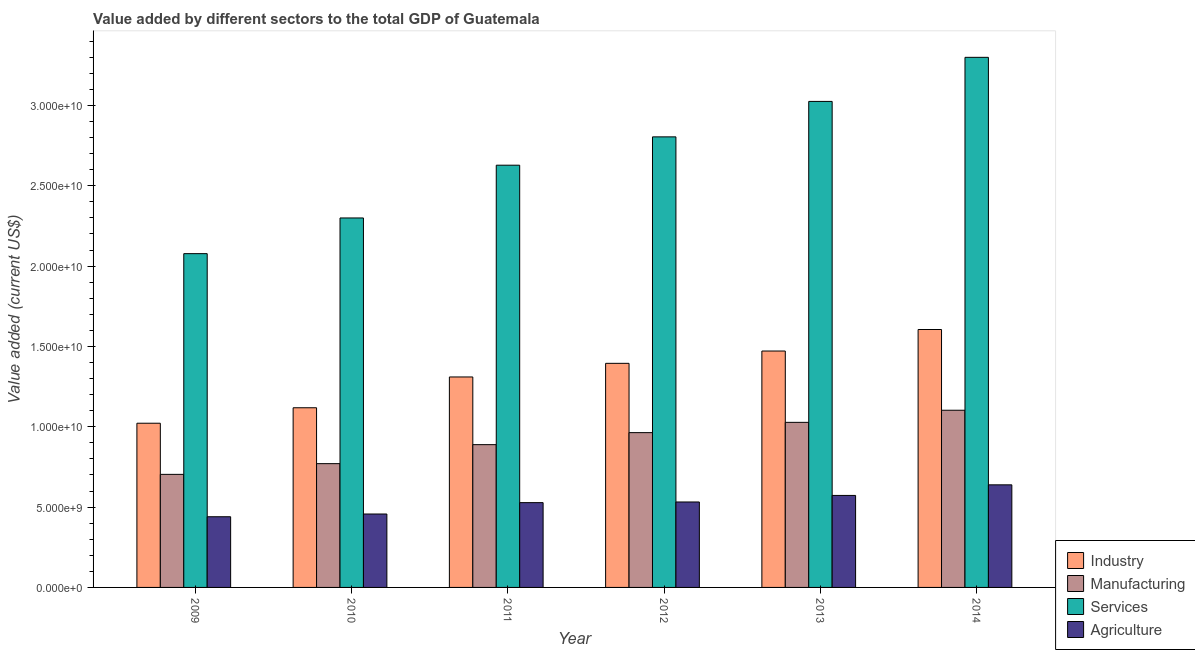Are the number of bars per tick equal to the number of legend labels?
Offer a terse response. Yes. In how many cases, is the number of bars for a given year not equal to the number of legend labels?
Keep it short and to the point. 0. What is the value added by industrial sector in 2011?
Your response must be concise. 1.31e+1. Across all years, what is the maximum value added by industrial sector?
Give a very brief answer. 1.61e+1. Across all years, what is the minimum value added by industrial sector?
Your answer should be compact. 1.02e+1. What is the total value added by industrial sector in the graph?
Offer a terse response. 7.92e+1. What is the difference between the value added by agricultural sector in 2011 and that in 2014?
Offer a terse response. -1.11e+09. What is the difference between the value added by agricultural sector in 2009 and the value added by services sector in 2012?
Provide a succinct answer. -9.19e+08. What is the average value added by industrial sector per year?
Keep it short and to the point. 1.32e+1. What is the ratio of the value added by services sector in 2009 to that in 2013?
Ensure brevity in your answer.  0.69. Is the value added by manufacturing sector in 2009 less than that in 2011?
Make the answer very short. Yes. Is the difference between the value added by services sector in 2011 and 2012 greater than the difference between the value added by industrial sector in 2011 and 2012?
Offer a terse response. No. What is the difference between the highest and the second highest value added by manufacturing sector?
Your response must be concise. 7.54e+08. What is the difference between the highest and the lowest value added by agricultural sector?
Your answer should be very brief. 1.99e+09. In how many years, is the value added by services sector greater than the average value added by services sector taken over all years?
Make the answer very short. 3. What does the 2nd bar from the left in 2010 represents?
Give a very brief answer. Manufacturing. What does the 3rd bar from the right in 2011 represents?
Your answer should be compact. Manufacturing. Does the graph contain grids?
Make the answer very short. No. Where does the legend appear in the graph?
Give a very brief answer. Bottom right. How many legend labels are there?
Give a very brief answer. 4. What is the title of the graph?
Your response must be concise. Value added by different sectors to the total GDP of Guatemala. Does "WHO" appear as one of the legend labels in the graph?
Provide a short and direct response. No. What is the label or title of the Y-axis?
Provide a short and direct response. Value added (current US$). What is the Value added (current US$) in Industry in 2009?
Your answer should be compact. 1.02e+1. What is the Value added (current US$) in Manufacturing in 2009?
Keep it short and to the point. 7.04e+09. What is the Value added (current US$) of Services in 2009?
Provide a short and direct response. 2.08e+1. What is the Value added (current US$) in Agriculture in 2009?
Give a very brief answer. 4.40e+09. What is the Value added (current US$) in Industry in 2010?
Give a very brief answer. 1.12e+1. What is the Value added (current US$) of Manufacturing in 2010?
Your answer should be very brief. 7.70e+09. What is the Value added (current US$) in Services in 2010?
Provide a succinct answer. 2.30e+1. What is the Value added (current US$) of Agriculture in 2010?
Offer a very short reply. 4.57e+09. What is the Value added (current US$) of Industry in 2011?
Your response must be concise. 1.31e+1. What is the Value added (current US$) of Manufacturing in 2011?
Keep it short and to the point. 8.89e+09. What is the Value added (current US$) of Services in 2011?
Keep it short and to the point. 2.63e+1. What is the Value added (current US$) in Agriculture in 2011?
Your answer should be very brief. 5.28e+09. What is the Value added (current US$) in Industry in 2012?
Your response must be concise. 1.39e+1. What is the Value added (current US$) of Manufacturing in 2012?
Offer a terse response. 9.63e+09. What is the Value added (current US$) of Services in 2012?
Your answer should be compact. 2.80e+1. What is the Value added (current US$) in Agriculture in 2012?
Ensure brevity in your answer.  5.32e+09. What is the Value added (current US$) of Industry in 2013?
Keep it short and to the point. 1.47e+1. What is the Value added (current US$) in Manufacturing in 2013?
Your answer should be very brief. 1.03e+1. What is the Value added (current US$) of Services in 2013?
Make the answer very short. 3.02e+1. What is the Value added (current US$) of Agriculture in 2013?
Provide a succinct answer. 5.73e+09. What is the Value added (current US$) in Industry in 2014?
Keep it short and to the point. 1.61e+1. What is the Value added (current US$) in Manufacturing in 2014?
Your answer should be compact. 1.10e+1. What is the Value added (current US$) in Services in 2014?
Offer a terse response. 3.30e+1. What is the Value added (current US$) of Agriculture in 2014?
Offer a terse response. 6.38e+09. Across all years, what is the maximum Value added (current US$) in Industry?
Your answer should be very brief. 1.61e+1. Across all years, what is the maximum Value added (current US$) of Manufacturing?
Your answer should be very brief. 1.10e+1. Across all years, what is the maximum Value added (current US$) in Services?
Keep it short and to the point. 3.30e+1. Across all years, what is the maximum Value added (current US$) in Agriculture?
Provide a short and direct response. 6.38e+09. Across all years, what is the minimum Value added (current US$) in Industry?
Your response must be concise. 1.02e+1. Across all years, what is the minimum Value added (current US$) of Manufacturing?
Ensure brevity in your answer.  7.04e+09. Across all years, what is the minimum Value added (current US$) of Services?
Provide a short and direct response. 2.08e+1. Across all years, what is the minimum Value added (current US$) in Agriculture?
Offer a terse response. 4.40e+09. What is the total Value added (current US$) of Industry in the graph?
Offer a terse response. 7.92e+1. What is the total Value added (current US$) of Manufacturing in the graph?
Offer a very short reply. 5.46e+1. What is the total Value added (current US$) of Services in the graph?
Provide a succinct answer. 1.61e+11. What is the total Value added (current US$) in Agriculture in the graph?
Make the answer very short. 3.17e+1. What is the difference between the Value added (current US$) of Industry in 2009 and that in 2010?
Keep it short and to the point. -9.63e+08. What is the difference between the Value added (current US$) in Manufacturing in 2009 and that in 2010?
Provide a short and direct response. -6.67e+08. What is the difference between the Value added (current US$) of Services in 2009 and that in 2010?
Your answer should be very brief. -2.22e+09. What is the difference between the Value added (current US$) of Agriculture in 2009 and that in 2010?
Keep it short and to the point. -1.71e+08. What is the difference between the Value added (current US$) of Industry in 2009 and that in 2011?
Give a very brief answer. -2.88e+09. What is the difference between the Value added (current US$) of Manufacturing in 2009 and that in 2011?
Keep it short and to the point. -1.85e+09. What is the difference between the Value added (current US$) of Services in 2009 and that in 2011?
Provide a succinct answer. -5.50e+09. What is the difference between the Value added (current US$) in Agriculture in 2009 and that in 2011?
Keep it short and to the point. -8.79e+08. What is the difference between the Value added (current US$) in Industry in 2009 and that in 2012?
Ensure brevity in your answer.  -3.73e+09. What is the difference between the Value added (current US$) in Manufacturing in 2009 and that in 2012?
Your answer should be compact. -2.60e+09. What is the difference between the Value added (current US$) of Services in 2009 and that in 2012?
Ensure brevity in your answer.  -7.27e+09. What is the difference between the Value added (current US$) of Agriculture in 2009 and that in 2012?
Offer a terse response. -9.19e+08. What is the difference between the Value added (current US$) in Industry in 2009 and that in 2013?
Provide a succinct answer. -4.49e+09. What is the difference between the Value added (current US$) of Manufacturing in 2009 and that in 2013?
Give a very brief answer. -3.24e+09. What is the difference between the Value added (current US$) in Services in 2009 and that in 2013?
Your answer should be very brief. -9.47e+09. What is the difference between the Value added (current US$) of Agriculture in 2009 and that in 2013?
Your response must be concise. -1.33e+09. What is the difference between the Value added (current US$) of Industry in 2009 and that in 2014?
Provide a short and direct response. -5.83e+09. What is the difference between the Value added (current US$) of Manufacturing in 2009 and that in 2014?
Keep it short and to the point. -3.99e+09. What is the difference between the Value added (current US$) of Services in 2009 and that in 2014?
Your answer should be compact. -1.22e+1. What is the difference between the Value added (current US$) of Agriculture in 2009 and that in 2014?
Give a very brief answer. -1.99e+09. What is the difference between the Value added (current US$) in Industry in 2010 and that in 2011?
Your answer should be compact. -1.92e+09. What is the difference between the Value added (current US$) of Manufacturing in 2010 and that in 2011?
Keep it short and to the point. -1.18e+09. What is the difference between the Value added (current US$) in Services in 2010 and that in 2011?
Provide a short and direct response. -3.28e+09. What is the difference between the Value added (current US$) in Agriculture in 2010 and that in 2011?
Offer a very short reply. -7.08e+08. What is the difference between the Value added (current US$) in Industry in 2010 and that in 2012?
Provide a short and direct response. -2.76e+09. What is the difference between the Value added (current US$) of Manufacturing in 2010 and that in 2012?
Provide a short and direct response. -1.93e+09. What is the difference between the Value added (current US$) of Services in 2010 and that in 2012?
Your answer should be very brief. -5.05e+09. What is the difference between the Value added (current US$) of Agriculture in 2010 and that in 2012?
Offer a very short reply. -7.48e+08. What is the difference between the Value added (current US$) in Industry in 2010 and that in 2013?
Your answer should be compact. -3.53e+09. What is the difference between the Value added (current US$) in Manufacturing in 2010 and that in 2013?
Ensure brevity in your answer.  -2.57e+09. What is the difference between the Value added (current US$) in Services in 2010 and that in 2013?
Provide a short and direct response. -7.25e+09. What is the difference between the Value added (current US$) in Agriculture in 2010 and that in 2013?
Your answer should be very brief. -1.16e+09. What is the difference between the Value added (current US$) of Industry in 2010 and that in 2014?
Your response must be concise. -4.87e+09. What is the difference between the Value added (current US$) of Manufacturing in 2010 and that in 2014?
Offer a terse response. -3.32e+09. What is the difference between the Value added (current US$) of Services in 2010 and that in 2014?
Your answer should be compact. -1.00e+1. What is the difference between the Value added (current US$) in Agriculture in 2010 and that in 2014?
Provide a short and direct response. -1.82e+09. What is the difference between the Value added (current US$) in Industry in 2011 and that in 2012?
Your response must be concise. -8.49e+08. What is the difference between the Value added (current US$) in Manufacturing in 2011 and that in 2012?
Offer a terse response. -7.48e+08. What is the difference between the Value added (current US$) of Services in 2011 and that in 2012?
Provide a succinct answer. -1.76e+09. What is the difference between the Value added (current US$) of Agriculture in 2011 and that in 2012?
Ensure brevity in your answer.  -4.02e+07. What is the difference between the Value added (current US$) in Industry in 2011 and that in 2013?
Provide a short and direct response. -1.61e+09. What is the difference between the Value added (current US$) in Manufacturing in 2011 and that in 2013?
Keep it short and to the point. -1.39e+09. What is the difference between the Value added (current US$) in Services in 2011 and that in 2013?
Offer a terse response. -3.97e+09. What is the difference between the Value added (current US$) in Agriculture in 2011 and that in 2013?
Give a very brief answer. -4.48e+08. What is the difference between the Value added (current US$) of Industry in 2011 and that in 2014?
Your answer should be compact. -2.95e+09. What is the difference between the Value added (current US$) in Manufacturing in 2011 and that in 2014?
Your answer should be compact. -2.14e+09. What is the difference between the Value added (current US$) of Services in 2011 and that in 2014?
Your answer should be compact. -6.71e+09. What is the difference between the Value added (current US$) in Agriculture in 2011 and that in 2014?
Offer a terse response. -1.11e+09. What is the difference between the Value added (current US$) in Industry in 2012 and that in 2013?
Your answer should be compact. -7.66e+08. What is the difference between the Value added (current US$) of Manufacturing in 2012 and that in 2013?
Offer a very short reply. -6.40e+08. What is the difference between the Value added (current US$) in Services in 2012 and that in 2013?
Your answer should be very brief. -2.21e+09. What is the difference between the Value added (current US$) of Agriculture in 2012 and that in 2013?
Your answer should be compact. -4.08e+08. What is the difference between the Value added (current US$) in Industry in 2012 and that in 2014?
Ensure brevity in your answer.  -2.11e+09. What is the difference between the Value added (current US$) of Manufacturing in 2012 and that in 2014?
Your response must be concise. -1.39e+09. What is the difference between the Value added (current US$) of Services in 2012 and that in 2014?
Your answer should be compact. -4.95e+09. What is the difference between the Value added (current US$) of Agriculture in 2012 and that in 2014?
Make the answer very short. -1.07e+09. What is the difference between the Value added (current US$) in Industry in 2013 and that in 2014?
Ensure brevity in your answer.  -1.34e+09. What is the difference between the Value added (current US$) of Manufacturing in 2013 and that in 2014?
Your answer should be compact. -7.54e+08. What is the difference between the Value added (current US$) in Services in 2013 and that in 2014?
Your answer should be very brief. -2.74e+09. What is the difference between the Value added (current US$) in Agriculture in 2013 and that in 2014?
Provide a short and direct response. -6.59e+08. What is the difference between the Value added (current US$) of Industry in 2009 and the Value added (current US$) of Manufacturing in 2010?
Your answer should be compact. 2.52e+09. What is the difference between the Value added (current US$) in Industry in 2009 and the Value added (current US$) in Services in 2010?
Offer a terse response. -1.28e+1. What is the difference between the Value added (current US$) in Industry in 2009 and the Value added (current US$) in Agriculture in 2010?
Provide a short and direct response. 5.65e+09. What is the difference between the Value added (current US$) of Manufacturing in 2009 and the Value added (current US$) of Services in 2010?
Ensure brevity in your answer.  -1.60e+1. What is the difference between the Value added (current US$) in Manufacturing in 2009 and the Value added (current US$) in Agriculture in 2010?
Provide a short and direct response. 2.47e+09. What is the difference between the Value added (current US$) in Services in 2009 and the Value added (current US$) in Agriculture in 2010?
Provide a short and direct response. 1.62e+1. What is the difference between the Value added (current US$) in Industry in 2009 and the Value added (current US$) in Manufacturing in 2011?
Ensure brevity in your answer.  1.33e+09. What is the difference between the Value added (current US$) in Industry in 2009 and the Value added (current US$) in Services in 2011?
Make the answer very short. -1.61e+1. What is the difference between the Value added (current US$) in Industry in 2009 and the Value added (current US$) in Agriculture in 2011?
Keep it short and to the point. 4.94e+09. What is the difference between the Value added (current US$) in Manufacturing in 2009 and the Value added (current US$) in Services in 2011?
Your answer should be very brief. -1.92e+1. What is the difference between the Value added (current US$) of Manufacturing in 2009 and the Value added (current US$) of Agriculture in 2011?
Make the answer very short. 1.76e+09. What is the difference between the Value added (current US$) of Services in 2009 and the Value added (current US$) of Agriculture in 2011?
Give a very brief answer. 1.55e+1. What is the difference between the Value added (current US$) in Industry in 2009 and the Value added (current US$) in Manufacturing in 2012?
Keep it short and to the point. 5.85e+08. What is the difference between the Value added (current US$) in Industry in 2009 and the Value added (current US$) in Services in 2012?
Your response must be concise. -1.78e+1. What is the difference between the Value added (current US$) of Industry in 2009 and the Value added (current US$) of Agriculture in 2012?
Make the answer very short. 4.90e+09. What is the difference between the Value added (current US$) in Manufacturing in 2009 and the Value added (current US$) in Services in 2012?
Provide a short and direct response. -2.10e+1. What is the difference between the Value added (current US$) of Manufacturing in 2009 and the Value added (current US$) of Agriculture in 2012?
Your answer should be compact. 1.72e+09. What is the difference between the Value added (current US$) of Services in 2009 and the Value added (current US$) of Agriculture in 2012?
Keep it short and to the point. 1.55e+1. What is the difference between the Value added (current US$) of Industry in 2009 and the Value added (current US$) of Manufacturing in 2013?
Ensure brevity in your answer.  -5.47e+07. What is the difference between the Value added (current US$) in Industry in 2009 and the Value added (current US$) in Services in 2013?
Your response must be concise. -2.00e+1. What is the difference between the Value added (current US$) of Industry in 2009 and the Value added (current US$) of Agriculture in 2013?
Give a very brief answer. 4.49e+09. What is the difference between the Value added (current US$) of Manufacturing in 2009 and the Value added (current US$) of Services in 2013?
Your answer should be very brief. -2.32e+1. What is the difference between the Value added (current US$) of Manufacturing in 2009 and the Value added (current US$) of Agriculture in 2013?
Keep it short and to the point. 1.31e+09. What is the difference between the Value added (current US$) of Services in 2009 and the Value added (current US$) of Agriculture in 2013?
Ensure brevity in your answer.  1.50e+1. What is the difference between the Value added (current US$) of Industry in 2009 and the Value added (current US$) of Manufacturing in 2014?
Your answer should be very brief. -8.09e+08. What is the difference between the Value added (current US$) of Industry in 2009 and the Value added (current US$) of Services in 2014?
Give a very brief answer. -2.28e+1. What is the difference between the Value added (current US$) of Industry in 2009 and the Value added (current US$) of Agriculture in 2014?
Provide a short and direct response. 3.83e+09. What is the difference between the Value added (current US$) of Manufacturing in 2009 and the Value added (current US$) of Services in 2014?
Provide a succinct answer. -2.60e+1. What is the difference between the Value added (current US$) in Manufacturing in 2009 and the Value added (current US$) in Agriculture in 2014?
Provide a succinct answer. 6.52e+08. What is the difference between the Value added (current US$) in Services in 2009 and the Value added (current US$) in Agriculture in 2014?
Offer a terse response. 1.44e+1. What is the difference between the Value added (current US$) of Industry in 2010 and the Value added (current US$) of Manufacturing in 2011?
Ensure brevity in your answer.  2.30e+09. What is the difference between the Value added (current US$) in Industry in 2010 and the Value added (current US$) in Services in 2011?
Provide a short and direct response. -1.51e+1. What is the difference between the Value added (current US$) in Industry in 2010 and the Value added (current US$) in Agriculture in 2011?
Ensure brevity in your answer.  5.91e+09. What is the difference between the Value added (current US$) of Manufacturing in 2010 and the Value added (current US$) of Services in 2011?
Give a very brief answer. -1.86e+1. What is the difference between the Value added (current US$) of Manufacturing in 2010 and the Value added (current US$) of Agriculture in 2011?
Your response must be concise. 2.43e+09. What is the difference between the Value added (current US$) in Services in 2010 and the Value added (current US$) in Agriculture in 2011?
Your answer should be compact. 1.77e+1. What is the difference between the Value added (current US$) of Industry in 2010 and the Value added (current US$) of Manufacturing in 2012?
Offer a terse response. 1.55e+09. What is the difference between the Value added (current US$) in Industry in 2010 and the Value added (current US$) in Services in 2012?
Your answer should be compact. -1.69e+1. What is the difference between the Value added (current US$) of Industry in 2010 and the Value added (current US$) of Agriculture in 2012?
Give a very brief answer. 5.86e+09. What is the difference between the Value added (current US$) of Manufacturing in 2010 and the Value added (current US$) of Services in 2012?
Make the answer very short. -2.03e+1. What is the difference between the Value added (current US$) of Manufacturing in 2010 and the Value added (current US$) of Agriculture in 2012?
Keep it short and to the point. 2.39e+09. What is the difference between the Value added (current US$) in Services in 2010 and the Value added (current US$) in Agriculture in 2012?
Make the answer very short. 1.77e+1. What is the difference between the Value added (current US$) in Industry in 2010 and the Value added (current US$) in Manufacturing in 2013?
Provide a succinct answer. 9.09e+08. What is the difference between the Value added (current US$) in Industry in 2010 and the Value added (current US$) in Services in 2013?
Ensure brevity in your answer.  -1.91e+1. What is the difference between the Value added (current US$) in Industry in 2010 and the Value added (current US$) in Agriculture in 2013?
Keep it short and to the point. 5.46e+09. What is the difference between the Value added (current US$) of Manufacturing in 2010 and the Value added (current US$) of Services in 2013?
Keep it short and to the point. -2.25e+1. What is the difference between the Value added (current US$) in Manufacturing in 2010 and the Value added (current US$) in Agriculture in 2013?
Offer a very short reply. 1.98e+09. What is the difference between the Value added (current US$) in Services in 2010 and the Value added (current US$) in Agriculture in 2013?
Give a very brief answer. 1.73e+1. What is the difference between the Value added (current US$) of Industry in 2010 and the Value added (current US$) of Manufacturing in 2014?
Provide a succinct answer. 1.55e+08. What is the difference between the Value added (current US$) of Industry in 2010 and the Value added (current US$) of Services in 2014?
Provide a succinct answer. -2.18e+1. What is the difference between the Value added (current US$) of Industry in 2010 and the Value added (current US$) of Agriculture in 2014?
Offer a terse response. 4.80e+09. What is the difference between the Value added (current US$) in Manufacturing in 2010 and the Value added (current US$) in Services in 2014?
Offer a very short reply. -2.53e+1. What is the difference between the Value added (current US$) of Manufacturing in 2010 and the Value added (current US$) of Agriculture in 2014?
Your answer should be very brief. 1.32e+09. What is the difference between the Value added (current US$) in Services in 2010 and the Value added (current US$) in Agriculture in 2014?
Keep it short and to the point. 1.66e+1. What is the difference between the Value added (current US$) in Industry in 2011 and the Value added (current US$) in Manufacturing in 2012?
Your answer should be very brief. 3.46e+09. What is the difference between the Value added (current US$) of Industry in 2011 and the Value added (current US$) of Services in 2012?
Make the answer very short. -1.49e+1. What is the difference between the Value added (current US$) of Industry in 2011 and the Value added (current US$) of Agriculture in 2012?
Your answer should be very brief. 7.78e+09. What is the difference between the Value added (current US$) in Manufacturing in 2011 and the Value added (current US$) in Services in 2012?
Keep it short and to the point. -1.92e+1. What is the difference between the Value added (current US$) in Manufacturing in 2011 and the Value added (current US$) in Agriculture in 2012?
Your answer should be very brief. 3.57e+09. What is the difference between the Value added (current US$) in Services in 2011 and the Value added (current US$) in Agriculture in 2012?
Ensure brevity in your answer.  2.10e+1. What is the difference between the Value added (current US$) in Industry in 2011 and the Value added (current US$) in Manufacturing in 2013?
Your answer should be very brief. 2.82e+09. What is the difference between the Value added (current US$) in Industry in 2011 and the Value added (current US$) in Services in 2013?
Your response must be concise. -1.72e+1. What is the difference between the Value added (current US$) in Industry in 2011 and the Value added (current US$) in Agriculture in 2013?
Offer a terse response. 7.37e+09. What is the difference between the Value added (current US$) in Manufacturing in 2011 and the Value added (current US$) in Services in 2013?
Provide a short and direct response. -2.14e+1. What is the difference between the Value added (current US$) in Manufacturing in 2011 and the Value added (current US$) in Agriculture in 2013?
Your response must be concise. 3.16e+09. What is the difference between the Value added (current US$) of Services in 2011 and the Value added (current US$) of Agriculture in 2013?
Offer a terse response. 2.06e+1. What is the difference between the Value added (current US$) of Industry in 2011 and the Value added (current US$) of Manufacturing in 2014?
Provide a succinct answer. 2.07e+09. What is the difference between the Value added (current US$) of Industry in 2011 and the Value added (current US$) of Services in 2014?
Offer a very short reply. -1.99e+1. What is the difference between the Value added (current US$) of Industry in 2011 and the Value added (current US$) of Agriculture in 2014?
Give a very brief answer. 6.71e+09. What is the difference between the Value added (current US$) in Manufacturing in 2011 and the Value added (current US$) in Services in 2014?
Offer a terse response. -2.41e+1. What is the difference between the Value added (current US$) in Manufacturing in 2011 and the Value added (current US$) in Agriculture in 2014?
Keep it short and to the point. 2.50e+09. What is the difference between the Value added (current US$) in Services in 2011 and the Value added (current US$) in Agriculture in 2014?
Provide a succinct answer. 1.99e+1. What is the difference between the Value added (current US$) in Industry in 2012 and the Value added (current US$) in Manufacturing in 2013?
Your response must be concise. 3.67e+09. What is the difference between the Value added (current US$) in Industry in 2012 and the Value added (current US$) in Services in 2013?
Your answer should be very brief. -1.63e+1. What is the difference between the Value added (current US$) of Industry in 2012 and the Value added (current US$) of Agriculture in 2013?
Offer a very short reply. 8.22e+09. What is the difference between the Value added (current US$) in Manufacturing in 2012 and the Value added (current US$) in Services in 2013?
Offer a terse response. -2.06e+1. What is the difference between the Value added (current US$) in Manufacturing in 2012 and the Value added (current US$) in Agriculture in 2013?
Keep it short and to the point. 3.91e+09. What is the difference between the Value added (current US$) in Services in 2012 and the Value added (current US$) in Agriculture in 2013?
Your answer should be compact. 2.23e+1. What is the difference between the Value added (current US$) in Industry in 2012 and the Value added (current US$) in Manufacturing in 2014?
Keep it short and to the point. 2.92e+09. What is the difference between the Value added (current US$) of Industry in 2012 and the Value added (current US$) of Services in 2014?
Provide a succinct answer. -1.90e+1. What is the difference between the Value added (current US$) of Industry in 2012 and the Value added (current US$) of Agriculture in 2014?
Provide a succinct answer. 7.56e+09. What is the difference between the Value added (current US$) in Manufacturing in 2012 and the Value added (current US$) in Services in 2014?
Your answer should be very brief. -2.34e+1. What is the difference between the Value added (current US$) of Manufacturing in 2012 and the Value added (current US$) of Agriculture in 2014?
Your response must be concise. 3.25e+09. What is the difference between the Value added (current US$) of Services in 2012 and the Value added (current US$) of Agriculture in 2014?
Keep it short and to the point. 2.17e+1. What is the difference between the Value added (current US$) of Industry in 2013 and the Value added (current US$) of Manufacturing in 2014?
Make the answer very short. 3.69e+09. What is the difference between the Value added (current US$) in Industry in 2013 and the Value added (current US$) in Services in 2014?
Provide a short and direct response. -1.83e+1. What is the difference between the Value added (current US$) of Industry in 2013 and the Value added (current US$) of Agriculture in 2014?
Offer a very short reply. 8.33e+09. What is the difference between the Value added (current US$) of Manufacturing in 2013 and the Value added (current US$) of Services in 2014?
Offer a very short reply. -2.27e+1. What is the difference between the Value added (current US$) in Manufacturing in 2013 and the Value added (current US$) in Agriculture in 2014?
Offer a very short reply. 3.89e+09. What is the difference between the Value added (current US$) in Services in 2013 and the Value added (current US$) in Agriculture in 2014?
Keep it short and to the point. 2.39e+1. What is the average Value added (current US$) in Industry per year?
Your answer should be very brief. 1.32e+1. What is the average Value added (current US$) in Manufacturing per year?
Provide a short and direct response. 9.09e+09. What is the average Value added (current US$) of Services per year?
Provide a short and direct response. 2.69e+1. What is the average Value added (current US$) of Agriculture per year?
Provide a short and direct response. 5.28e+09. In the year 2009, what is the difference between the Value added (current US$) of Industry and Value added (current US$) of Manufacturing?
Your response must be concise. 3.18e+09. In the year 2009, what is the difference between the Value added (current US$) of Industry and Value added (current US$) of Services?
Ensure brevity in your answer.  -1.06e+1. In the year 2009, what is the difference between the Value added (current US$) in Industry and Value added (current US$) in Agriculture?
Offer a terse response. 5.82e+09. In the year 2009, what is the difference between the Value added (current US$) of Manufacturing and Value added (current US$) of Services?
Provide a short and direct response. -1.37e+1. In the year 2009, what is the difference between the Value added (current US$) in Manufacturing and Value added (current US$) in Agriculture?
Provide a short and direct response. 2.64e+09. In the year 2009, what is the difference between the Value added (current US$) of Services and Value added (current US$) of Agriculture?
Provide a succinct answer. 1.64e+1. In the year 2010, what is the difference between the Value added (current US$) in Industry and Value added (current US$) in Manufacturing?
Give a very brief answer. 3.48e+09. In the year 2010, what is the difference between the Value added (current US$) in Industry and Value added (current US$) in Services?
Provide a short and direct response. -1.18e+1. In the year 2010, what is the difference between the Value added (current US$) of Industry and Value added (current US$) of Agriculture?
Provide a short and direct response. 6.61e+09. In the year 2010, what is the difference between the Value added (current US$) of Manufacturing and Value added (current US$) of Services?
Make the answer very short. -1.53e+1. In the year 2010, what is the difference between the Value added (current US$) of Manufacturing and Value added (current US$) of Agriculture?
Offer a very short reply. 3.13e+09. In the year 2010, what is the difference between the Value added (current US$) in Services and Value added (current US$) in Agriculture?
Offer a terse response. 1.84e+1. In the year 2011, what is the difference between the Value added (current US$) of Industry and Value added (current US$) of Manufacturing?
Your answer should be compact. 4.21e+09. In the year 2011, what is the difference between the Value added (current US$) of Industry and Value added (current US$) of Services?
Offer a terse response. -1.32e+1. In the year 2011, what is the difference between the Value added (current US$) in Industry and Value added (current US$) in Agriculture?
Make the answer very short. 7.82e+09. In the year 2011, what is the difference between the Value added (current US$) of Manufacturing and Value added (current US$) of Services?
Offer a terse response. -1.74e+1. In the year 2011, what is the difference between the Value added (current US$) in Manufacturing and Value added (current US$) in Agriculture?
Your answer should be compact. 3.61e+09. In the year 2011, what is the difference between the Value added (current US$) of Services and Value added (current US$) of Agriculture?
Ensure brevity in your answer.  2.10e+1. In the year 2012, what is the difference between the Value added (current US$) of Industry and Value added (current US$) of Manufacturing?
Your answer should be compact. 4.31e+09. In the year 2012, what is the difference between the Value added (current US$) of Industry and Value added (current US$) of Services?
Offer a very short reply. -1.41e+1. In the year 2012, what is the difference between the Value added (current US$) of Industry and Value added (current US$) of Agriculture?
Make the answer very short. 8.63e+09. In the year 2012, what is the difference between the Value added (current US$) of Manufacturing and Value added (current US$) of Services?
Your answer should be very brief. -1.84e+1. In the year 2012, what is the difference between the Value added (current US$) in Manufacturing and Value added (current US$) in Agriculture?
Make the answer very short. 4.32e+09. In the year 2012, what is the difference between the Value added (current US$) in Services and Value added (current US$) in Agriculture?
Make the answer very short. 2.27e+1. In the year 2013, what is the difference between the Value added (current US$) in Industry and Value added (current US$) in Manufacturing?
Offer a very short reply. 4.44e+09. In the year 2013, what is the difference between the Value added (current US$) of Industry and Value added (current US$) of Services?
Ensure brevity in your answer.  -1.55e+1. In the year 2013, what is the difference between the Value added (current US$) in Industry and Value added (current US$) in Agriculture?
Your answer should be compact. 8.99e+09. In the year 2013, what is the difference between the Value added (current US$) in Manufacturing and Value added (current US$) in Services?
Give a very brief answer. -2.00e+1. In the year 2013, what is the difference between the Value added (current US$) in Manufacturing and Value added (current US$) in Agriculture?
Offer a terse response. 4.55e+09. In the year 2013, what is the difference between the Value added (current US$) of Services and Value added (current US$) of Agriculture?
Ensure brevity in your answer.  2.45e+1. In the year 2014, what is the difference between the Value added (current US$) of Industry and Value added (current US$) of Manufacturing?
Make the answer very short. 5.02e+09. In the year 2014, what is the difference between the Value added (current US$) in Industry and Value added (current US$) in Services?
Your response must be concise. -1.69e+1. In the year 2014, what is the difference between the Value added (current US$) of Industry and Value added (current US$) of Agriculture?
Offer a terse response. 9.67e+09. In the year 2014, what is the difference between the Value added (current US$) of Manufacturing and Value added (current US$) of Services?
Keep it short and to the point. -2.20e+1. In the year 2014, what is the difference between the Value added (current US$) of Manufacturing and Value added (current US$) of Agriculture?
Your answer should be very brief. 4.64e+09. In the year 2014, what is the difference between the Value added (current US$) in Services and Value added (current US$) in Agriculture?
Your response must be concise. 2.66e+1. What is the ratio of the Value added (current US$) of Industry in 2009 to that in 2010?
Keep it short and to the point. 0.91. What is the ratio of the Value added (current US$) in Manufacturing in 2009 to that in 2010?
Make the answer very short. 0.91. What is the ratio of the Value added (current US$) in Services in 2009 to that in 2010?
Ensure brevity in your answer.  0.9. What is the ratio of the Value added (current US$) in Agriculture in 2009 to that in 2010?
Offer a very short reply. 0.96. What is the ratio of the Value added (current US$) in Industry in 2009 to that in 2011?
Your answer should be very brief. 0.78. What is the ratio of the Value added (current US$) in Manufacturing in 2009 to that in 2011?
Give a very brief answer. 0.79. What is the ratio of the Value added (current US$) of Services in 2009 to that in 2011?
Your answer should be very brief. 0.79. What is the ratio of the Value added (current US$) in Agriculture in 2009 to that in 2011?
Your response must be concise. 0.83. What is the ratio of the Value added (current US$) in Industry in 2009 to that in 2012?
Provide a succinct answer. 0.73. What is the ratio of the Value added (current US$) in Manufacturing in 2009 to that in 2012?
Your answer should be compact. 0.73. What is the ratio of the Value added (current US$) in Services in 2009 to that in 2012?
Make the answer very short. 0.74. What is the ratio of the Value added (current US$) in Agriculture in 2009 to that in 2012?
Offer a very short reply. 0.83. What is the ratio of the Value added (current US$) of Industry in 2009 to that in 2013?
Ensure brevity in your answer.  0.69. What is the ratio of the Value added (current US$) in Manufacturing in 2009 to that in 2013?
Provide a succinct answer. 0.68. What is the ratio of the Value added (current US$) in Services in 2009 to that in 2013?
Make the answer very short. 0.69. What is the ratio of the Value added (current US$) of Agriculture in 2009 to that in 2013?
Provide a succinct answer. 0.77. What is the ratio of the Value added (current US$) of Industry in 2009 to that in 2014?
Keep it short and to the point. 0.64. What is the ratio of the Value added (current US$) in Manufacturing in 2009 to that in 2014?
Provide a short and direct response. 0.64. What is the ratio of the Value added (current US$) of Services in 2009 to that in 2014?
Offer a very short reply. 0.63. What is the ratio of the Value added (current US$) of Agriculture in 2009 to that in 2014?
Ensure brevity in your answer.  0.69. What is the ratio of the Value added (current US$) in Industry in 2010 to that in 2011?
Ensure brevity in your answer.  0.85. What is the ratio of the Value added (current US$) in Manufacturing in 2010 to that in 2011?
Your response must be concise. 0.87. What is the ratio of the Value added (current US$) of Services in 2010 to that in 2011?
Ensure brevity in your answer.  0.88. What is the ratio of the Value added (current US$) of Agriculture in 2010 to that in 2011?
Provide a short and direct response. 0.87. What is the ratio of the Value added (current US$) in Industry in 2010 to that in 2012?
Keep it short and to the point. 0.8. What is the ratio of the Value added (current US$) in Manufacturing in 2010 to that in 2012?
Provide a succinct answer. 0.8. What is the ratio of the Value added (current US$) of Services in 2010 to that in 2012?
Offer a terse response. 0.82. What is the ratio of the Value added (current US$) of Agriculture in 2010 to that in 2012?
Offer a very short reply. 0.86. What is the ratio of the Value added (current US$) of Industry in 2010 to that in 2013?
Make the answer very short. 0.76. What is the ratio of the Value added (current US$) in Manufacturing in 2010 to that in 2013?
Offer a very short reply. 0.75. What is the ratio of the Value added (current US$) of Services in 2010 to that in 2013?
Keep it short and to the point. 0.76. What is the ratio of the Value added (current US$) of Agriculture in 2010 to that in 2013?
Provide a short and direct response. 0.8. What is the ratio of the Value added (current US$) of Industry in 2010 to that in 2014?
Offer a terse response. 0.7. What is the ratio of the Value added (current US$) in Manufacturing in 2010 to that in 2014?
Keep it short and to the point. 0.7. What is the ratio of the Value added (current US$) of Services in 2010 to that in 2014?
Your answer should be very brief. 0.7. What is the ratio of the Value added (current US$) of Agriculture in 2010 to that in 2014?
Keep it short and to the point. 0.72. What is the ratio of the Value added (current US$) of Industry in 2011 to that in 2012?
Your answer should be compact. 0.94. What is the ratio of the Value added (current US$) of Manufacturing in 2011 to that in 2012?
Provide a succinct answer. 0.92. What is the ratio of the Value added (current US$) of Services in 2011 to that in 2012?
Provide a succinct answer. 0.94. What is the ratio of the Value added (current US$) of Industry in 2011 to that in 2013?
Your answer should be very brief. 0.89. What is the ratio of the Value added (current US$) in Manufacturing in 2011 to that in 2013?
Offer a very short reply. 0.86. What is the ratio of the Value added (current US$) of Services in 2011 to that in 2013?
Offer a very short reply. 0.87. What is the ratio of the Value added (current US$) of Agriculture in 2011 to that in 2013?
Your response must be concise. 0.92. What is the ratio of the Value added (current US$) of Industry in 2011 to that in 2014?
Make the answer very short. 0.82. What is the ratio of the Value added (current US$) of Manufacturing in 2011 to that in 2014?
Your answer should be compact. 0.81. What is the ratio of the Value added (current US$) in Services in 2011 to that in 2014?
Your answer should be very brief. 0.8. What is the ratio of the Value added (current US$) in Agriculture in 2011 to that in 2014?
Give a very brief answer. 0.83. What is the ratio of the Value added (current US$) of Industry in 2012 to that in 2013?
Provide a short and direct response. 0.95. What is the ratio of the Value added (current US$) of Manufacturing in 2012 to that in 2013?
Your answer should be very brief. 0.94. What is the ratio of the Value added (current US$) in Services in 2012 to that in 2013?
Ensure brevity in your answer.  0.93. What is the ratio of the Value added (current US$) in Agriculture in 2012 to that in 2013?
Your answer should be very brief. 0.93. What is the ratio of the Value added (current US$) in Industry in 2012 to that in 2014?
Provide a succinct answer. 0.87. What is the ratio of the Value added (current US$) of Manufacturing in 2012 to that in 2014?
Your answer should be compact. 0.87. What is the ratio of the Value added (current US$) in Agriculture in 2012 to that in 2014?
Your answer should be compact. 0.83. What is the ratio of the Value added (current US$) of Industry in 2013 to that in 2014?
Ensure brevity in your answer.  0.92. What is the ratio of the Value added (current US$) of Manufacturing in 2013 to that in 2014?
Provide a short and direct response. 0.93. What is the ratio of the Value added (current US$) of Services in 2013 to that in 2014?
Offer a terse response. 0.92. What is the ratio of the Value added (current US$) of Agriculture in 2013 to that in 2014?
Your answer should be very brief. 0.9. What is the difference between the highest and the second highest Value added (current US$) of Industry?
Provide a succinct answer. 1.34e+09. What is the difference between the highest and the second highest Value added (current US$) in Manufacturing?
Keep it short and to the point. 7.54e+08. What is the difference between the highest and the second highest Value added (current US$) of Services?
Your answer should be compact. 2.74e+09. What is the difference between the highest and the second highest Value added (current US$) in Agriculture?
Provide a short and direct response. 6.59e+08. What is the difference between the highest and the lowest Value added (current US$) of Industry?
Your response must be concise. 5.83e+09. What is the difference between the highest and the lowest Value added (current US$) of Manufacturing?
Keep it short and to the point. 3.99e+09. What is the difference between the highest and the lowest Value added (current US$) of Services?
Ensure brevity in your answer.  1.22e+1. What is the difference between the highest and the lowest Value added (current US$) in Agriculture?
Give a very brief answer. 1.99e+09. 